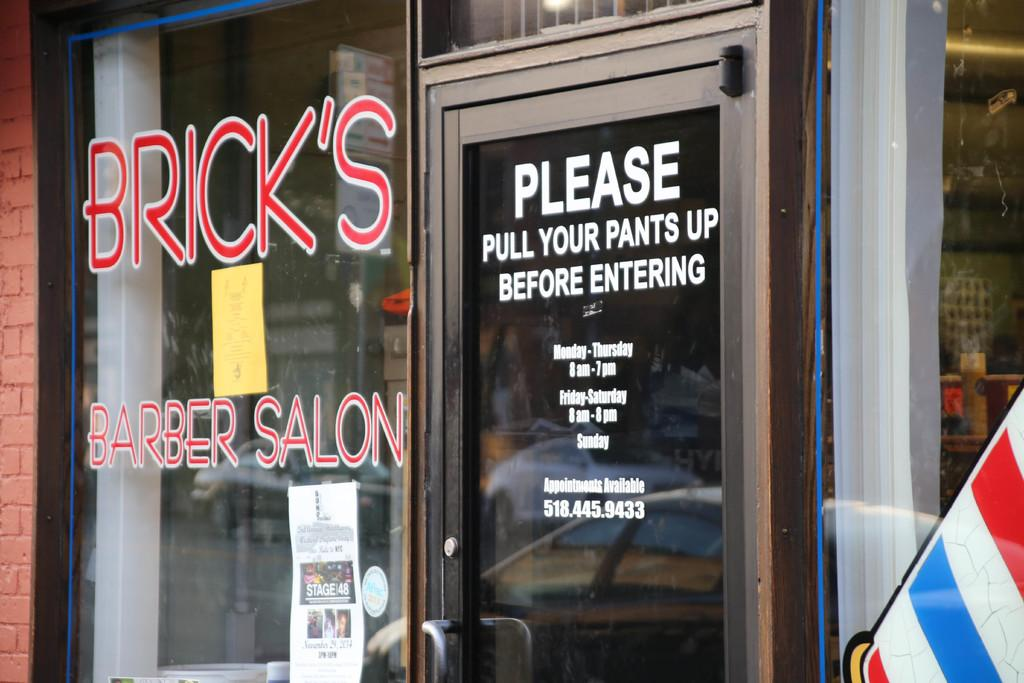What is a prominent feature in the image? There is a door in the image. What can be found on the door? There is text on the door. What type of wall is visible in the image? There is no wall visible in the image; it only features a door with text on it. How does the image relate to the summer season? The image does not provide any information about the season or weather, so it cannot be determined if it relates to summer. 